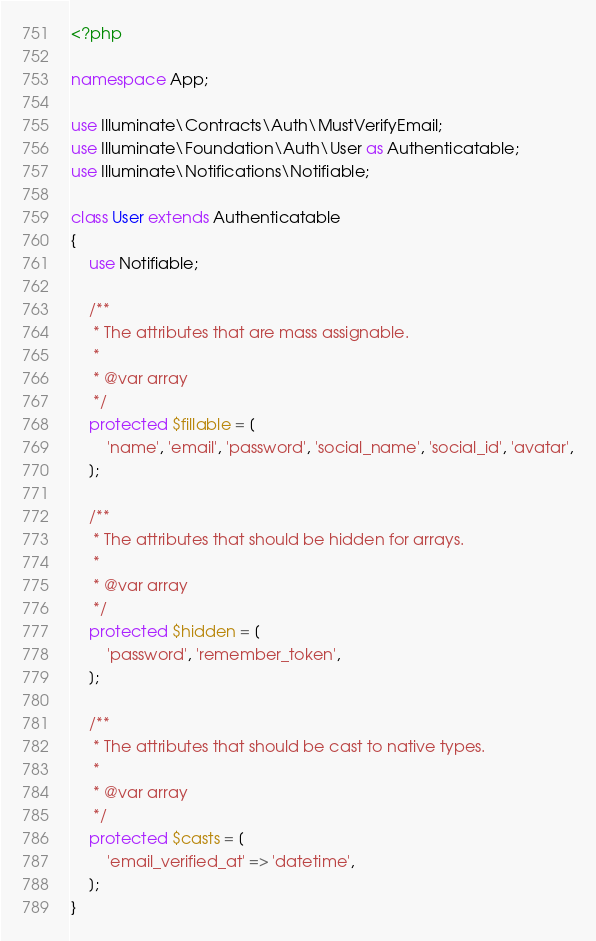Convert code to text. <code><loc_0><loc_0><loc_500><loc_500><_PHP_><?php

namespace App;

use Illuminate\Contracts\Auth\MustVerifyEmail;
use Illuminate\Foundation\Auth\User as Authenticatable;
use Illuminate\Notifications\Notifiable;

class User extends Authenticatable
{
    use Notifiable;

    /**
     * The attributes that are mass assignable.
     *
     * @var array
     */
    protected $fillable = [
        'name', 'email', 'password', 'social_name', 'social_id', 'avatar',
    ];

    /**
     * The attributes that should be hidden for arrays.
     *
     * @var array
     */
    protected $hidden = [
        'password', 'remember_token',
    ];

    /**
     * The attributes that should be cast to native types.
     *
     * @var array
     */
    protected $casts = [
        'email_verified_at' => 'datetime',
    ];
}
</code> 